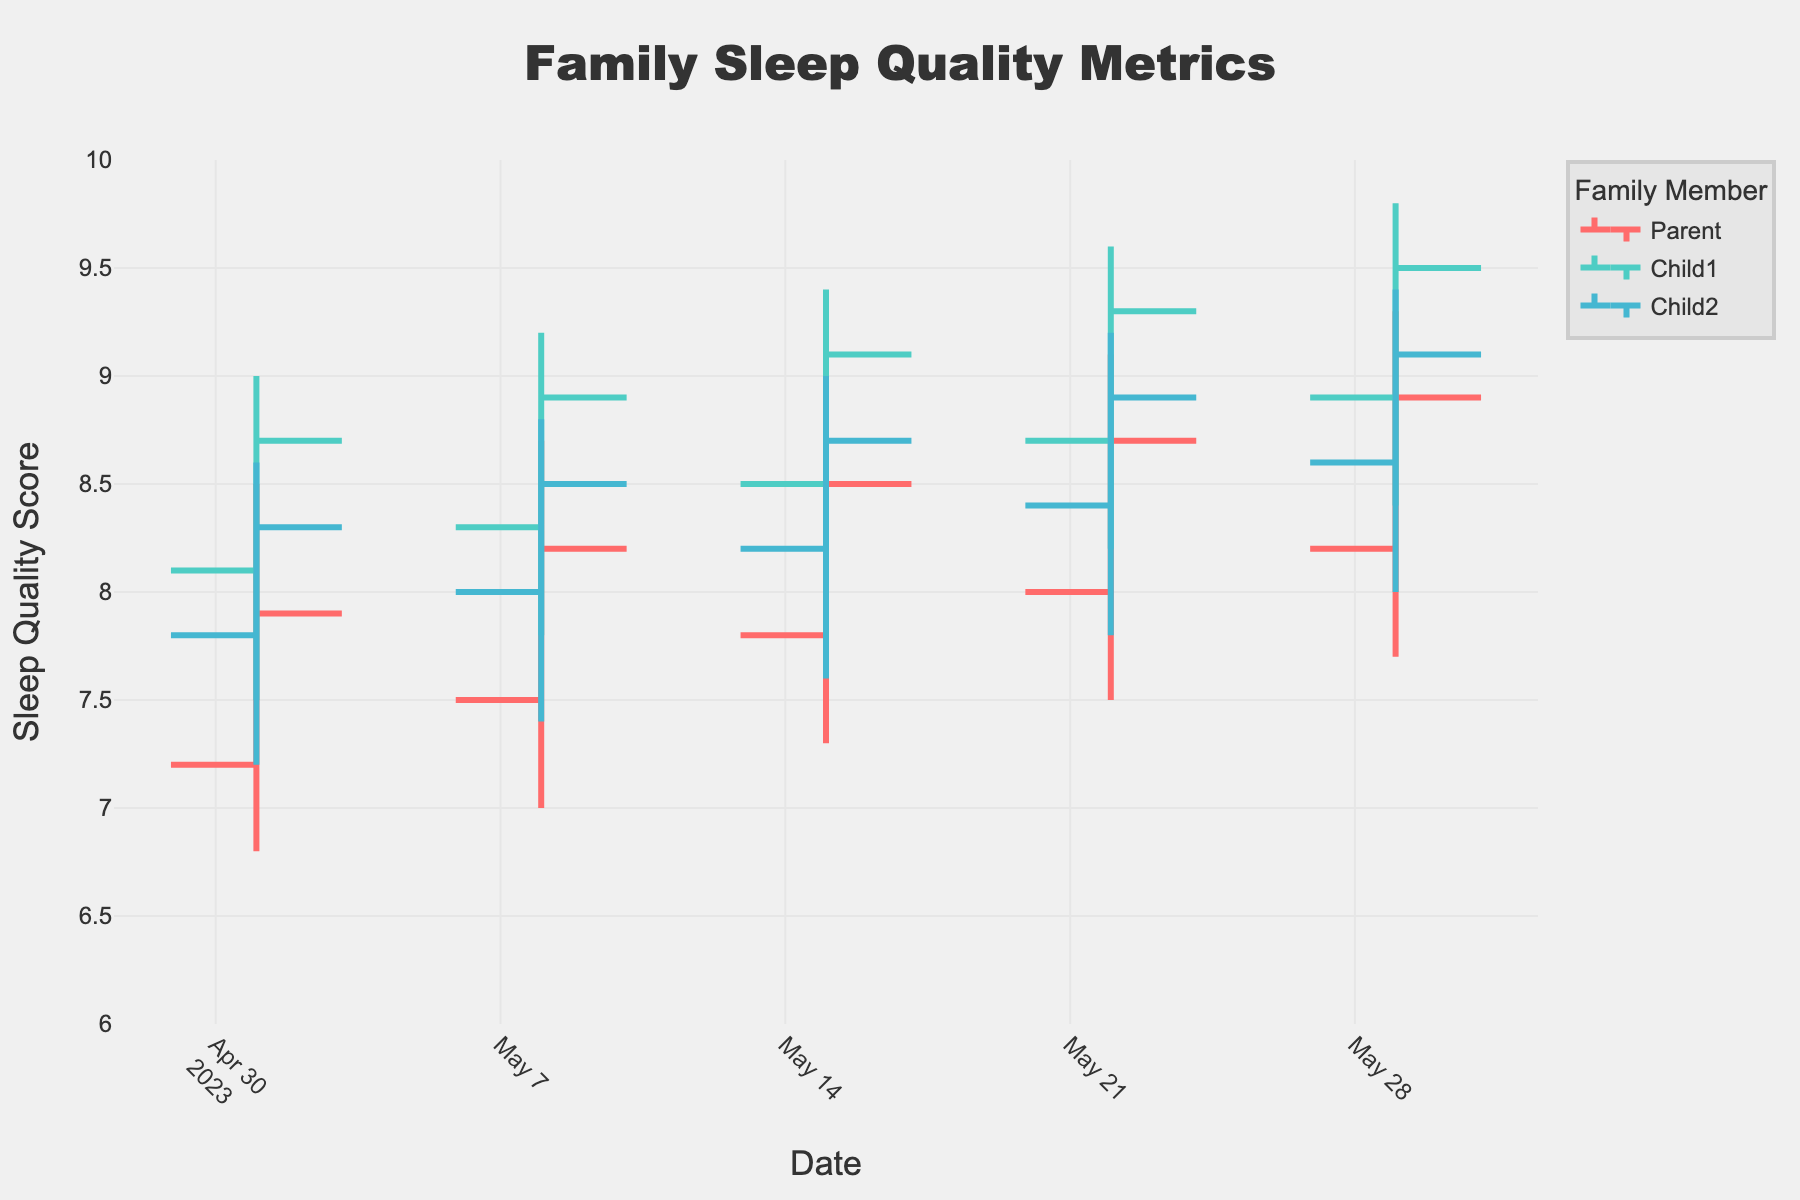How many data points are there for each family member in the figure? Count the number of data points for each family member: Parent (5), Child1 (5), Child2 (5).
Answer: 5 What is the highest sleep quality score recorded for Child2 throughout the month? Identify the highest values in the 'High' column for Child2 across all dates, which is 9.4 on May 29.
Answer: 9.4 What is the average closing sleep quality score for the Parent throughout the month? Sum the closing scores for the Parent (7.9 + 8.2 + 8.5 + 8.7 + 8.9) and divide by the number of data points (5): (7.9 + 8.2 + 8.5 + 8.7 + 8.9) / 5 = 8.44.
Answer: 8.44 Which family member showed the lowest sleep quality score during any week? Compare the lowest 'Low' values across all family members: Parent (6.8 on May 1), Child1 (7.5 on May 1), Child2 (7.2 on May 1). The lowest is Parent with 6.8.
Answer: Parent Between Parent and Child1, who had the steadiest sleep quality trend, and how can you tell? Compare the range (High-Low) for each week: Parent's ranges (1.7, 1.7, 1.6, 1.6, 1.6), Child1's ranges (1.5, 1.4, 1.4, 1.4, 1.4). Smaller ranges indicate steadier trends, thus Child1 had the steadiest trend.
Answer: Child1 Did any family member's sleep quality score improve every single week? Check the 'Close' values sequentially for improving trends: Parent (7.9, 8.2, 8.5, 8.7, 8.9), Child1 (8.7, 8.9, 9.1, 9.3, 9.5), Child2 (8.3, 8.5, 8.7, 8.9, 9.1). All members showed improvement each week.
Answer: Yes What was the total change in closing sleep quality scores for Child1 from the beginning to the end of the month? Subtract the closing score on May 1 from May 29 for Child1: 9.5 - 8.7 = 0.8.
Answer: 0.8 Between May 22 and May 29, which family member had the largest decrease in their closing sleep quality score? Check the difference in closing scores between these dates: Parent (8.9 - 8.7 = 0.2), Child1 (9.5 - 9.3 = 0.2), Child2 (9.1 - 8.9 = 0.2). All members had a decrease of 0.2.
Answer: All What is the percentage change in the high values for Child2 from May 1 to May 29? Calculate the percentage change: ((High on May 29 - High on May 1) / High on May 1) * 100 = ((9.4 - 8.6) / 8.6) * 100 ≈ 9.3%.
Answer: 9.3% 